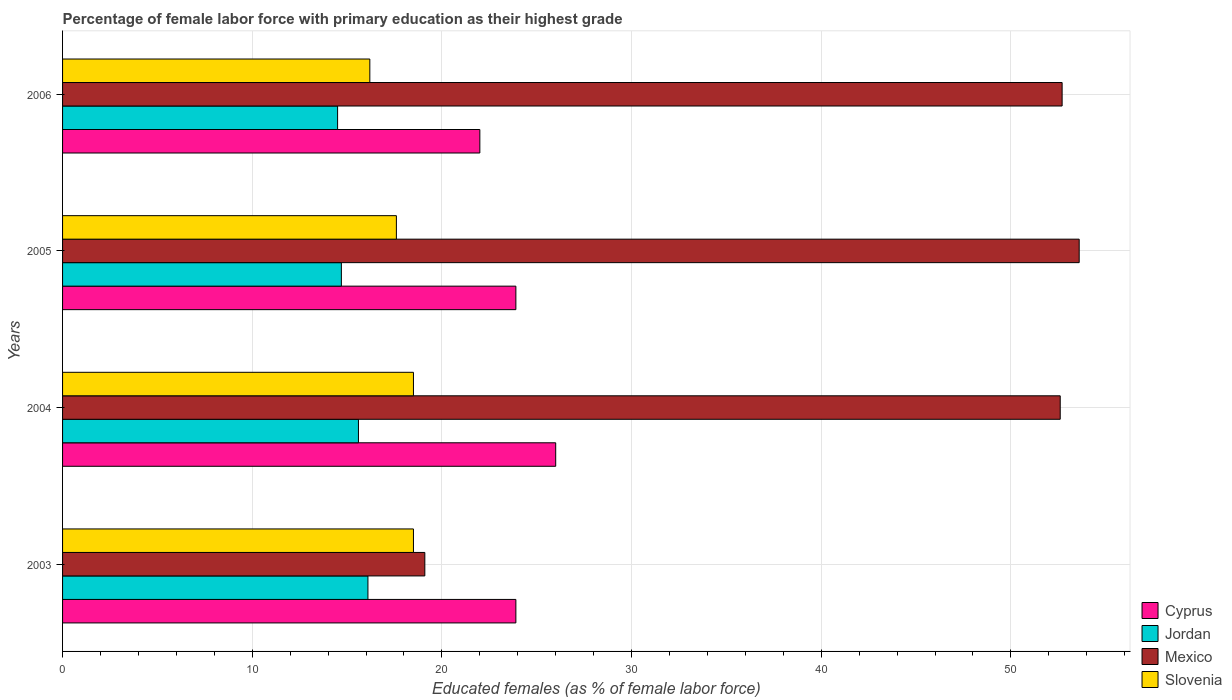How many different coloured bars are there?
Your answer should be very brief. 4. How many groups of bars are there?
Offer a terse response. 4. Are the number of bars on each tick of the Y-axis equal?
Provide a short and direct response. Yes. How many bars are there on the 4th tick from the bottom?
Keep it short and to the point. 4. In how many cases, is the number of bars for a given year not equal to the number of legend labels?
Give a very brief answer. 0. What is the percentage of female labor force with primary education in Jordan in 2005?
Your response must be concise. 14.7. Across all years, what is the minimum percentage of female labor force with primary education in Slovenia?
Provide a short and direct response. 16.2. In which year was the percentage of female labor force with primary education in Cyprus maximum?
Keep it short and to the point. 2004. In which year was the percentage of female labor force with primary education in Slovenia minimum?
Offer a terse response. 2006. What is the total percentage of female labor force with primary education in Mexico in the graph?
Keep it short and to the point. 178. What is the difference between the percentage of female labor force with primary education in Slovenia in 2004 and that in 2005?
Make the answer very short. 0.9. What is the difference between the percentage of female labor force with primary education in Slovenia in 2004 and the percentage of female labor force with primary education in Cyprus in 2003?
Provide a short and direct response. -5.4. What is the average percentage of female labor force with primary education in Mexico per year?
Provide a short and direct response. 44.5. In the year 2003, what is the difference between the percentage of female labor force with primary education in Cyprus and percentage of female labor force with primary education in Jordan?
Your response must be concise. 7.8. In how many years, is the percentage of female labor force with primary education in Slovenia greater than 30 %?
Keep it short and to the point. 0. What is the ratio of the percentage of female labor force with primary education in Jordan in 2003 to that in 2006?
Your answer should be very brief. 1.11. What is the difference between the highest and the second highest percentage of female labor force with primary education in Mexico?
Make the answer very short. 0.9. What is the difference between the highest and the lowest percentage of female labor force with primary education in Mexico?
Ensure brevity in your answer.  34.5. Is the sum of the percentage of female labor force with primary education in Mexico in 2003 and 2006 greater than the maximum percentage of female labor force with primary education in Cyprus across all years?
Your answer should be compact. Yes. What does the 3rd bar from the top in 2005 represents?
Provide a short and direct response. Jordan. Is it the case that in every year, the sum of the percentage of female labor force with primary education in Jordan and percentage of female labor force with primary education in Cyprus is greater than the percentage of female labor force with primary education in Mexico?
Your answer should be very brief. No. Are the values on the major ticks of X-axis written in scientific E-notation?
Provide a short and direct response. No. Does the graph contain any zero values?
Keep it short and to the point. No. Does the graph contain grids?
Offer a very short reply. Yes. Where does the legend appear in the graph?
Your answer should be very brief. Bottom right. How many legend labels are there?
Keep it short and to the point. 4. What is the title of the graph?
Your answer should be very brief. Percentage of female labor force with primary education as their highest grade. What is the label or title of the X-axis?
Offer a terse response. Educated females (as % of female labor force). What is the label or title of the Y-axis?
Your answer should be very brief. Years. What is the Educated females (as % of female labor force) in Cyprus in 2003?
Offer a very short reply. 23.9. What is the Educated females (as % of female labor force) in Jordan in 2003?
Provide a succinct answer. 16.1. What is the Educated females (as % of female labor force) in Mexico in 2003?
Your answer should be very brief. 19.1. What is the Educated females (as % of female labor force) of Slovenia in 2003?
Provide a succinct answer. 18.5. What is the Educated females (as % of female labor force) of Jordan in 2004?
Provide a short and direct response. 15.6. What is the Educated females (as % of female labor force) in Mexico in 2004?
Keep it short and to the point. 52.6. What is the Educated females (as % of female labor force) of Cyprus in 2005?
Give a very brief answer. 23.9. What is the Educated females (as % of female labor force) in Jordan in 2005?
Your response must be concise. 14.7. What is the Educated females (as % of female labor force) of Mexico in 2005?
Your response must be concise. 53.6. What is the Educated females (as % of female labor force) in Slovenia in 2005?
Ensure brevity in your answer.  17.6. What is the Educated females (as % of female labor force) of Jordan in 2006?
Offer a terse response. 14.5. What is the Educated females (as % of female labor force) of Mexico in 2006?
Provide a succinct answer. 52.7. What is the Educated females (as % of female labor force) of Slovenia in 2006?
Provide a short and direct response. 16.2. Across all years, what is the maximum Educated females (as % of female labor force) in Jordan?
Your answer should be compact. 16.1. Across all years, what is the maximum Educated females (as % of female labor force) of Mexico?
Provide a short and direct response. 53.6. Across all years, what is the minimum Educated females (as % of female labor force) in Cyprus?
Ensure brevity in your answer.  22. Across all years, what is the minimum Educated females (as % of female labor force) in Jordan?
Provide a succinct answer. 14.5. Across all years, what is the minimum Educated females (as % of female labor force) of Mexico?
Offer a very short reply. 19.1. Across all years, what is the minimum Educated females (as % of female labor force) in Slovenia?
Your answer should be very brief. 16.2. What is the total Educated females (as % of female labor force) in Cyprus in the graph?
Provide a short and direct response. 95.8. What is the total Educated females (as % of female labor force) of Jordan in the graph?
Make the answer very short. 60.9. What is the total Educated females (as % of female labor force) in Mexico in the graph?
Your response must be concise. 178. What is the total Educated females (as % of female labor force) of Slovenia in the graph?
Offer a very short reply. 70.8. What is the difference between the Educated females (as % of female labor force) of Jordan in 2003 and that in 2004?
Your answer should be compact. 0.5. What is the difference between the Educated females (as % of female labor force) of Mexico in 2003 and that in 2004?
Provide a succinct answer. -33.5. What is the difference between the Educated females (as % of female labor force) of Slovenia in 2003 and that in 2004?
Provide a short and direct response. 0. What is the difference between the Educated females (as % of female labor force) of Jordan in 2003 and that in 2005?
Your answer should be compact. 1.4. What is the difference between the Educated females (as % of female labor force) in Mexico in 2003 and that in 2005?
Your answer should be compact. -34.5. What is the difference between the Educated females (as % of female labor force) of Slovenia in 2003 and that in 2005?
Provide a short and direct response. 0.9. What is the difference between the Educated females (as % of female labor force) of Cyprus in 2003 and that in 2006?
Ensure brevity in your answer.  1.9. What is the difference between the Educated females (as % of female labor force) in Mexico in 2003 and that in 2006?
Your response must be concise. -33.6. What is the difference between the Educated females (as % of female labor force) of Jordan in 2004 and that in 2005?
Your answer should be compact. 0.9. What is the difference between the Educated females (as % of female labor force) in Cyprus in 2004 and that in 2006?
Keep it short and to the point. 4. What is the difference between the Educated females (as % of female labor force) in Mexico in 2004 and that in 2006?
Ensure brevity in your answer.  -0.1. What is the difference between the Educated females (as % of female labor force) of Slovenia in 2004 and that in 2006?
Your answer should be compact. 2.3. What is the difference between the Educated females (as % of female labor force) in Mexico in 2005 and that in 2006?
Give a very brief answer. 0.9. What is the difference between the Educated females (as % of female labor force) in Cyprus in 2003 and the Educated females (as % of female labor force) in Jordan in 2004?
Your answer should be very brief. 8.3. What is the difference between the Educated females (as % of female labor force) of Cyprus in 2003 and the Educated females (as % of female labor force) of Mexico in 2004?
Offer a terse response. -28.7. What is the difference between the Educated females (as % of female labor force) of Jordan in 2003 and the Educated females (as % of female labor force) of Mexico in 2004?
Offer a very short reply. -36.5. What is the difference between the Educated females (as % of female labor force) in Mexico in 2003 and the Educated females (as % of female labor force) in Slovenia in 2004?
Make the answer very short. 0.6. What is the difference between the Educated females (as % of female labor force) in Cyprus in 2003 and the Educated females (as % of female labor force) in Jordan in 2005?
Offer a terse response. 9.2. What is the difference between the Educated females (as % of female labor force) in Cyprus in 2003 and the Educated females (as % of female labor force) in Mexico in 2005?
Provide a short and direct response. -29.7. What is the difference between the Educated females (as % of female labor force) in Cyprus in 2003 and the Educated females (as % of female labor force) in Slovenia in 2005?
Provide a short and direct response. 6.3. What is the difference between the Educated females (as % of female labor force) in Jordan in 2003 and the Educated females (as % of female labor force) in Mexico in 2005?
Give a very brief answer. -37.5. What is the difference between the Educated females (as % of female labor force) of Mexico in 2003 and the Educated females (as % of female labor force) of Slovenia in 2005?
Make the answer very short. 1.5. What is the difference between the Educated females (as % of female labor force) of Cyprus in 2003 and the Educated females (as % of female labor force) of Jordan in 2006?
Offer a very short reply. 9.4. What is the difference between the Educated females (as % of female labor force) of Cyprus in 2003 and the Educated females (as % of female labor force) of Mexico in 2006?
Keep it short and to the point. -28.8. What is the difference between the Educated females (as % of female labor force) of Jordan in 2003 and the Educated females (as % of female labor force) of Mexico in 2006?
Provide a succinct answer. -36.6. What is the difference between the Educated females (as % of female labor force) of Jordan in 2003 and the Educated females (as % of female labor force) of Slovenia in 2006?
Your answer should be compact. -0.1. What is the difference between the Educated females (as % of female labor force) in Mexico in 2003 and the Educated females (as % of female labor force) in Slovenia in 2006?
Your answer should be very brief. 2.9. What is the difference between the Educated females (as % of female labor force) in Cyprus in 2004 and the Educated females (as % of female labor force) in Mexico in 2005?
Offer a terse response. -27.6. What is the difference between the Educated females (as % of female labor force) in Jordan in 2004 and the Educated females (as % of female labor force) in Mexico in 2005?
Your response must be concise. -38. What is the difference between the Educated females (as % of female labor force) of Jordan in 2004 and the Educated females (as % of female labor force) of Slovenia in 2005?
Give a very brief answer. -2. What is the difference between the Educated females (as % of female labor force) of Cyprus in 2004 and the Educated females (as % of female labor force) of Jordan in 2006?
Provide a succinct answer. 11.5. What is the difference between the Educated females (as % of female labor force) in Cyprus in 2004 and the Educated females (as % of female labor force) in Mexico in 2006?
Offer a terse response. -26.7. What is the difference between the Educated females (as % of female labor force) in Cyprus in 2004 and the Educated females (as % of female labor force) in Slovenia in 2006?
Your answer should be very brief. 9.8. What is the difference between the Educated females (as % of female labor force) in Jordan in 2004 and the Educated females (as % of female labor force) in Mexico in 2006?
Make the answer very short. -37.1. What is the difference between the Educated females (as % of female labor force) in Jordan in 2004 and the Educated females (as % of female labor force) in Slovenia in 2006?
Ensure brevity in your answer.  -0.6. What is the difference between the Educated females (as % of female labor force) in Mexico in 2004 and the Educated females (as % of female labor force) in Slovenia in 2006?
Your answer should be compact. 36.4. What is the difference between the Educated females (as % of female labor force) in Cyprus in 2005 and the Educated females (as % of female labor force) in Mexico in 2006?
Your response must be concise. -28.8. What is the difference between the Educated females (as % of female labor force) in Jordan in 2005 and the Educated females (as % of female labor force) in Mexico in 2006?
Ensure brevity in your answer.  -38. What is the difference between the Educated females (as % of female labor force) in Jordan in 2005 and the Educated females (as % of female labor force) in Slovenia in 2006?
Provide a short and direct response. -1.5. What is the difference between the Educated females (as % of female labor force) in Mexico in 2005 and the Educated females (as % of female labor force) in Slovenia in 2006?
Ensure brevity in your answer.  37.4. What is the average Educated females (as % of female labor force) of Cyprus per year?
Ensure brevity in your answer.  23.95. What is the average Educated females (as % of female labor force) of Jordan per year?
Give a very brief answer. 15.22. What is the average Educated females (as % of female labor force) of Mexico per year?
Provide a succinct answer. 44.5. In the year 2003, what is the difference between the Educated females (as % of female labor force) in Cyprus and Educated females (as % of female labor force) in Jordan?
Offer a terse response. 7.8. In the year 2003, what is the difference between the Educated females (as % of female labor force) in Cyprus and Educated females (as % of female labor force) in Mexico?
Provide a succinct answer. 4.8. In the year 2003, what is the difference between the Educated females (as % of female labor force) in Cyprus and Educated females (as % of female labor force) in Slovenia?
Keep it short and to the point. 5.4. In the year 2003, what is the difference between the Educated females (as % of female labor force) in Jordan and Educated females (as % of female labor force) in Mexico?
Give a very brief answer. -3. In the year 2003, what is the difference between the Educated females (as % of female labor force) of Mexico and Educated females (as % of female labor force) of Slovenia?
Give a very brief answer. 0.6. In the year 2004, what is the difference between the Educated females (as % of female labor force) in Cyprus and Educated females (as % of female labor force) in Mexico?
Give a very brief answer. -26.6. In the year 2004, what is the difference between the Educated females (as % of female labor force) in Jordan and Educated females (as % of female labor force) in Mexico?
Make the answer very short. -37. In the year 2004, what is the difference between the Educated females (as % of female labor force) in Jordan and Educated females (as % of female labor force) in Slovenia?
Offer a very short reply. -2.9. In the year 2004, what is the difference between the Educated females (as % of female labor force) of Mexico and Educated females (as % of female labor force) of Slovenia?
Keep it short and to the point. 34.1. In the year 2005, what is the difference between the Educated females (as % of female labor force) of Cyprus and Educated females (as % of female labor force) of Jordan?
Your answer should be very brief. 9.2. In the year 2005, what is the difference between the Educated females (as % of female labor force) in Cyprus and Educated females (as % of female labor force) in Mexico?
Make the answer very short. -29.7. In the year 2005, what is the difference between the Educated females (as % of female labor force) of Cyprus and Educated females (as % of female labor force) of Slovenia?
Provide a short and direct response. 6.3. In the year 2005, what is the difference between the Educated females (as % of female labor force) of Jordan and Educated females (as % of female labor force) of Mexico?
Ensure brevity in your answer.  -38.9. In the year 2005, what is the difference between the Educated females (as % of female labor force) in Jordan and Educated females (as % of female labor force) in Slovenia?
Your answer should be very brief. -2.9. In the year 2005, what is the difference between the Educated females (as % of female labor force) in Mexico and Educated females (as % of female labor force) in Slovenia?
Your answer should be very brief. 36. In the year 2006, what is the difference between the Educated females (as % of female labor force) in Cyprus and Educated females (as % of female labor force) in Jordan?
Offer a very short reply. 7.5. In the year 2006, what is the difference between the Educated females (as % of female labor force) of Cyprus and Educated females (as % of female labor force) of Mexico?
Provide a succinct answer. -30.7. In the year 2006, what is the difference between the Educated females (as % of female labor force) of Cyprus and Educated females (as % of female labor force) of Slovenia?
Offer a terse response. 5.8. In the year 2006, what is the difference between the Educated females (as % of female labor force) in Jordan and Educated females (as % of female labor force) in Mexico?
Offer a very short reply. -38.2. In the year 2006, what is the difference between the Educated females (as % of female labor force) in Mexico and Educated females (as % of female labor force) in Slovenia?
Make the answer very short. 36.5. What is the ratio of the Educated females (as % of female labor force) in Cyprus in 2003 to that in 2004?
Your answer should be very brief. 0.92. What is the ratio of the Educated females (as % of female labor force) of Jordan in 2003 to that in 2004?
Provide a short and direct response. 1.03. What is the ratio of the Educated females (as % of female labor force) of Mexico in 2003 to that in 2004?
Offer a terse response. 0.36. What is the ratio of the Educated females (as % of female labor force) in Cyprus in 2003 to that in 2005?
Provide a short and direct response. 1. What is the ratio of the Educated females (as % of female labor force) in Jordan in 2003 to that in 2005?
Your answer should be very brief. 1.1. What is the ratio of the Educated females (as % of female labor force) of Mexico in 2003 to that in 2005?
Your response must be concise. 0.36. What is the ratio of the Educated females (as % of female labor force) of Slovenia in 2003 to that in 2005?
Ensure brevity in your answer.  1.05. What is the ratio of the Educated females (as % of female labor force) of Cyprus in 2003 to that in 2006?
Your response must be concise. 1.09. What is the ratio of the Educated females (as % of female labor force) in Jordan in 2003 to that in 2006?
Offer a very short reply. 1.11. What is the ratio of the Educated females (as % of female labor force) of Mexico in 2003 to that in 2006?
Keep it short and to the point. 0.36. What is the ratio of the Educated females (as % of female labor force) in Slovenia in 2003 to that in 2006?
Keep it short and to the point. 1.14. What is the ratio of the Educated females (as % of female labor force) in Cyprus in 2004 to that in 2005?
Give a very brief answer. 1.09. What is the ratio of the Educated females (as % of female labor force) of Jordan in 2004 to that in 2005?
Your answer should be very brief. 1.06. What is the ratio of the Educated females (as % of female labor force) of Mexico in 2004 to that in 2005?
Provide a short and direct response. 0.98. What is the ratio of the Educated females (as % of female labor force) in Slovenia in 2004 to that in 2005?
Make the answer very short. 1.05. What is the ratio of the Educated females (as % of female labor force) in Cyprus in 2004 to that in 2006?
Your answer should be compact. 1.18. What is the ratio of the Educated females (as % of female labor force) in Jordan in 2004 to that in 2006?
Provide a short and direct response. 1.08. What is the ratio of the Educated females (as % of female labor force) in Mexico in 2004 to that in 2006?
Offer a terse response. 1. What is the ratio of the Educated females (as % of female labor force) of Slovenia in 2004 to that in 2006?
Offer a very short reply. 1.14. What is the ratio of the Educated females (as % of female labor force) of Cyprus in 2005 to that in 2006?
Make the answer very short. 1.09. What is the ratio of the Educated females (as % of female labor force) in Jordan in 2005 to that in 2006?
Offer a very short reply. 1.01. What is the ratio of the Educated females (as % of female labor force) in Mexico in 2005 to that in 2006?
Your response must be concise. 1.02. What is the ratio of the Educated females (as % of female labor force) of Slovenia in 2005 to that in 2006?
Provide a short and direct response. 1.09. What is the difference between the highest and the second highest Educated females (as % of female labor force) in Cyprus?
Offer a terse response. 2.1. What is the difference between the highest and the second highest Educated females (as % of female labor force) of Jordan?
Offer a very short reply. 0.5. What is the difference between the highest and the second highest Educated females (as % of female labor force) of Slovenia?
Make the answer very short. 0. What is the difference between the highest and the lowest Educated females (as % of female labor force) in Cyprus?
Your answer should be compact. 4. What is the difference between the highest and the lowest Educated females (as % of female labor force) of Mexico?
Offer a terse response. 34.5. 